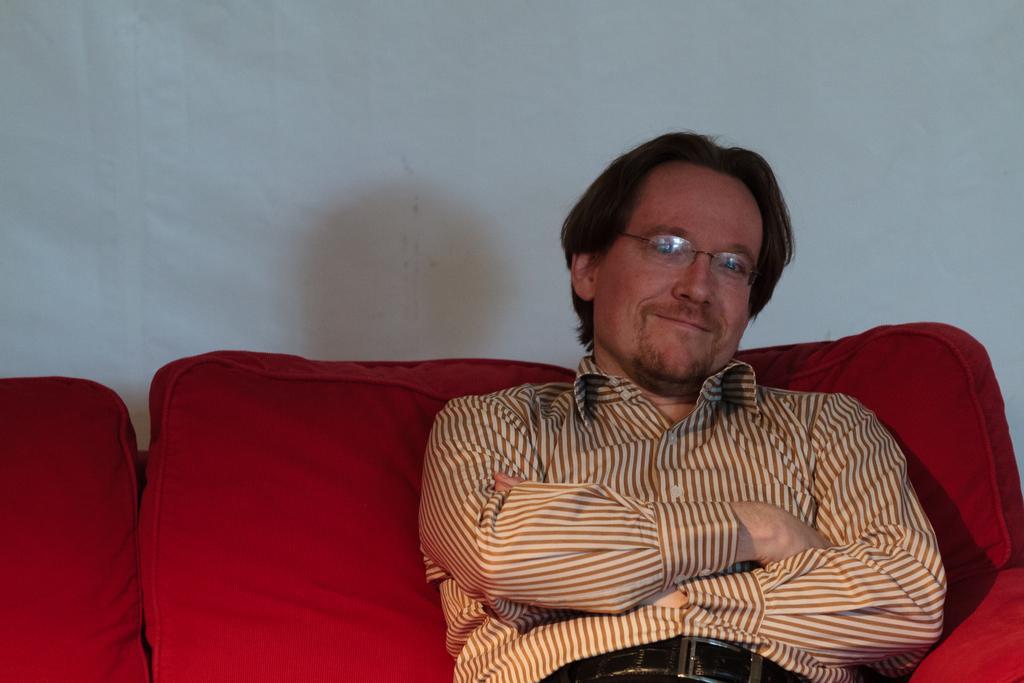Could you give a brief overview of what you see in this image? This image is taken indoors. In the background there is a wall. In the middle of the image a man is sitting on the couch and he is with a smiling face. The couch is red in color. 